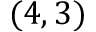<formula> <loc_0><loc_0><loc_500><loc_500>( 4 , 3 )</formula> 